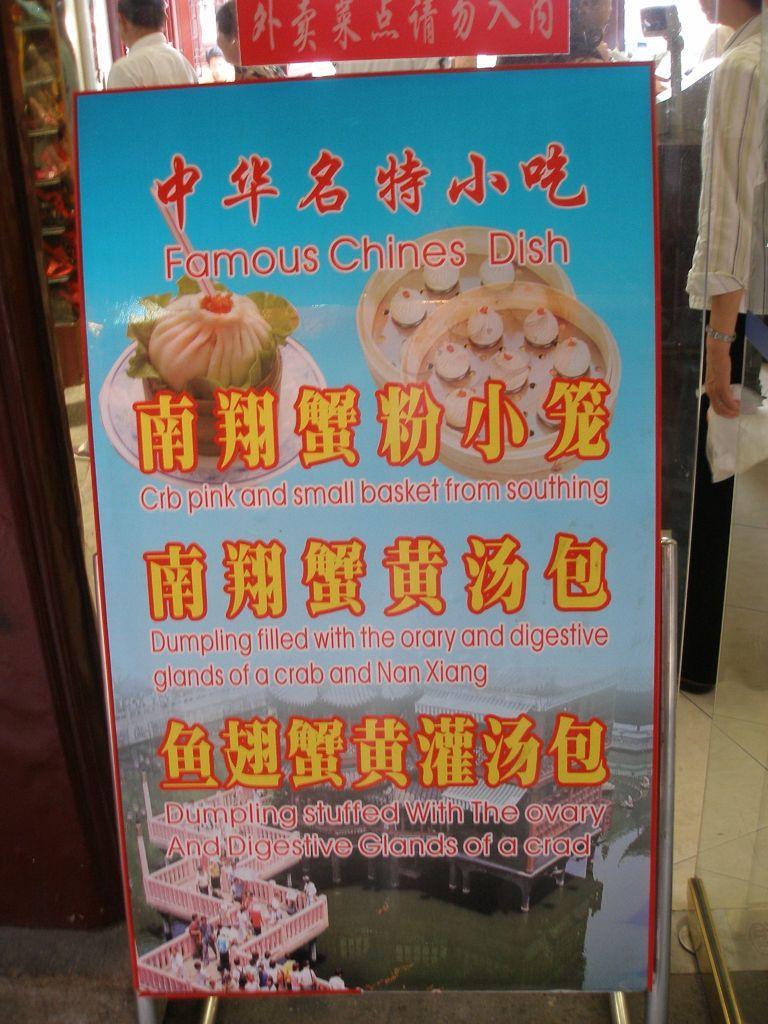In one or two sentences, can you explain what this image depicts? In this image I see a board on which there is something written and I see the depiction of food and the buildings and I see number of people and in the background I see few people. 